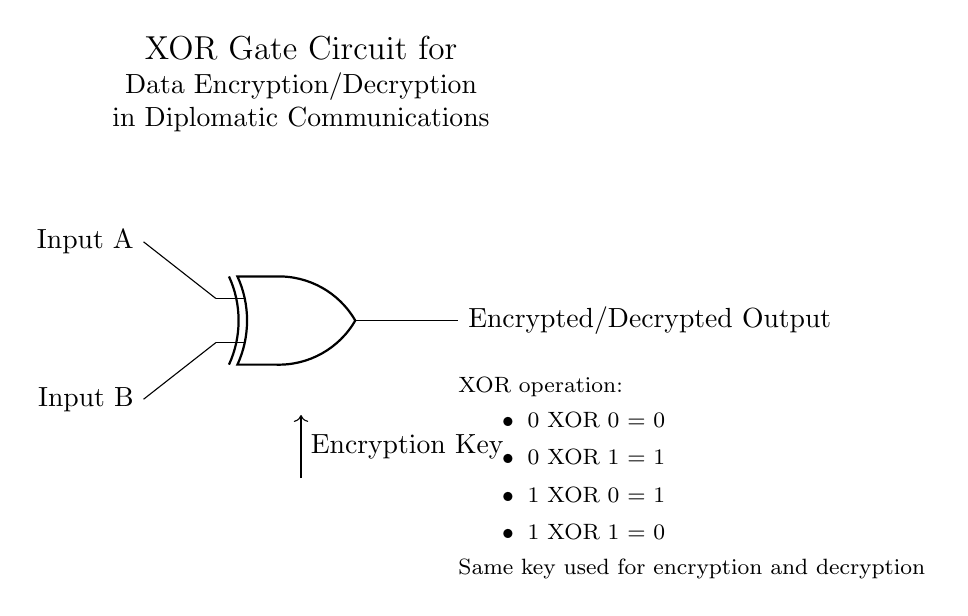What type of logic gate is illustrated? The diagram clearly shows an XOR gate, indicated by the port symbol used in the circuit. The gate's shape and its designation in the logic functionality suggest its type as exclusive OR.
Answer: XOR gate How many inputs does the XOR gate have? The diagram displays two input lines leading into the XOR gate. Each line corresponds to one of the inputs necessary for the XOR operation.
Answer: Two inputs What is the output of the XOR gate when both inputs are 1? According to the XOR operation table provided in the diagram, the output when both inputs are 1 is 0, as the operation yields false when both inputs are true.
Answer: 0 What is the purpose of the second line coming from the bottom of the circuit? The line labeled "Encryption Key" below the gate signifies that it's an additional input essential for the encryption and decryption process. This input helps modulate the other data inputs for secure communications.
Answer: Encryption key What will be the output if Input A is 0 and Input B is 1? Referring to the XOR operation details, if Input A is 0 and Input B is 1, the output results in 1. This is derived from the rule that states 0 XOR 1 equals 1.
Answer: 1 What can be inferred about the encryption method used in this circuit? The diagram states that the same key is used for both encryption and decryption, which implies that the XOR operation is symmetric in nature, making it suitable for this purpose in secure diplomatic communications.
Answer: Same key What does the XOR gate symbolize in the context of diplomatic communications? The XOR gate represents the mechanism used for secure data transmission, as it cross-relates the inputs through exclusive or logic, ensuring confidentiality and safe communication.
Answer: Data encryption/decryption 